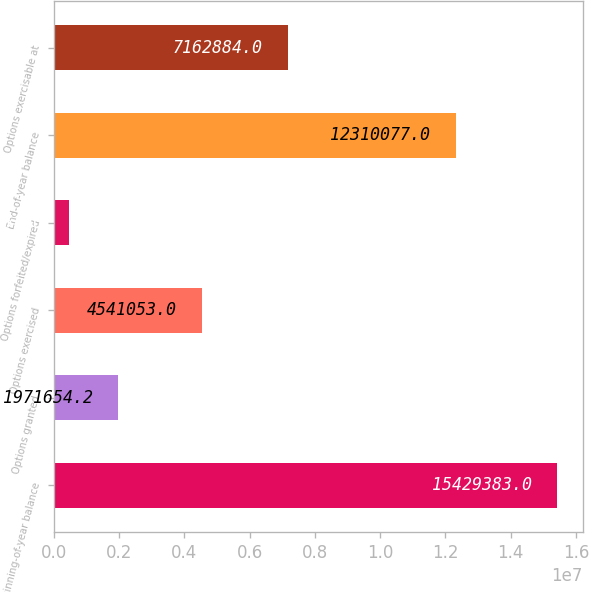Convert chart to OTSL. <chart><loc_0><loc_0><loc_500><loc_500><bar_chart><fcel>Beginning-of-year balance<fcel>Options granted<fcel>Options exercised<fcel>Options forfeited/expired<fcel>End-of-year balance<fcel>Options exercisable at<nl><fcel>1.54294e+07<fcel>1.97165e+06<fcel>4.54105e+06<fcel>476351<fcel>1.23101e+07<fcel>7.16288e+06<nl></chart> 